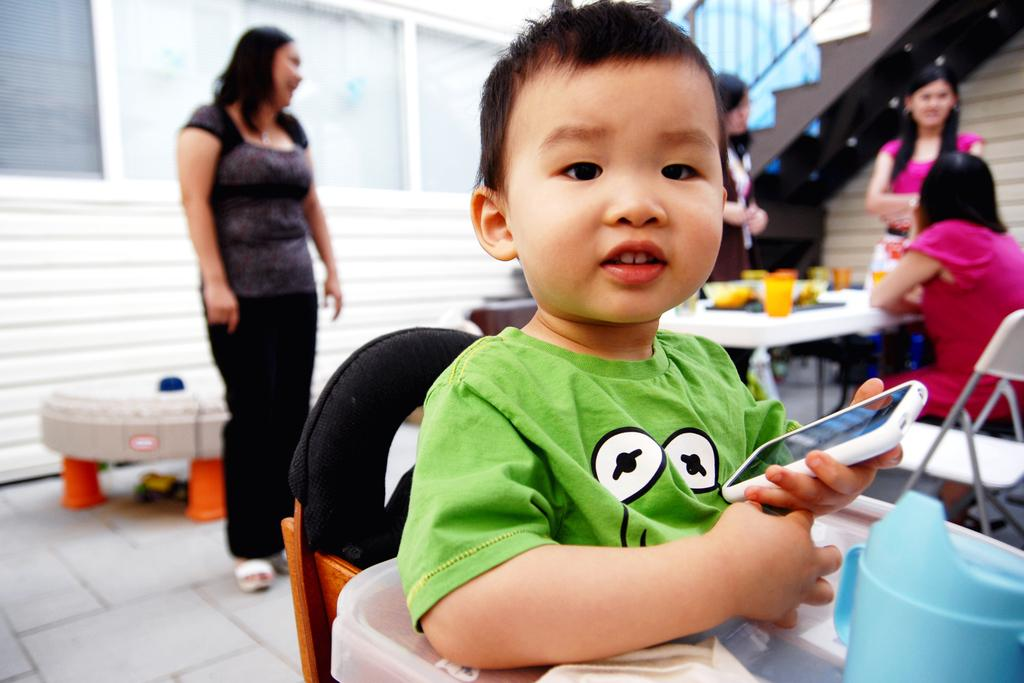Who is the main subject in the image? There is a woman standing in the image. Can you describe the other person in the image? There is a boy in the image. What is the boy holding in his hand? The boy is holding a smartphone in his hand. What is the boy's expression in the image? The boy is smiling. What type of bear can be seen participating in the discussion with the woman in the image? There is no bear present in the image, and therefore no discussion with the woman can be observed. 